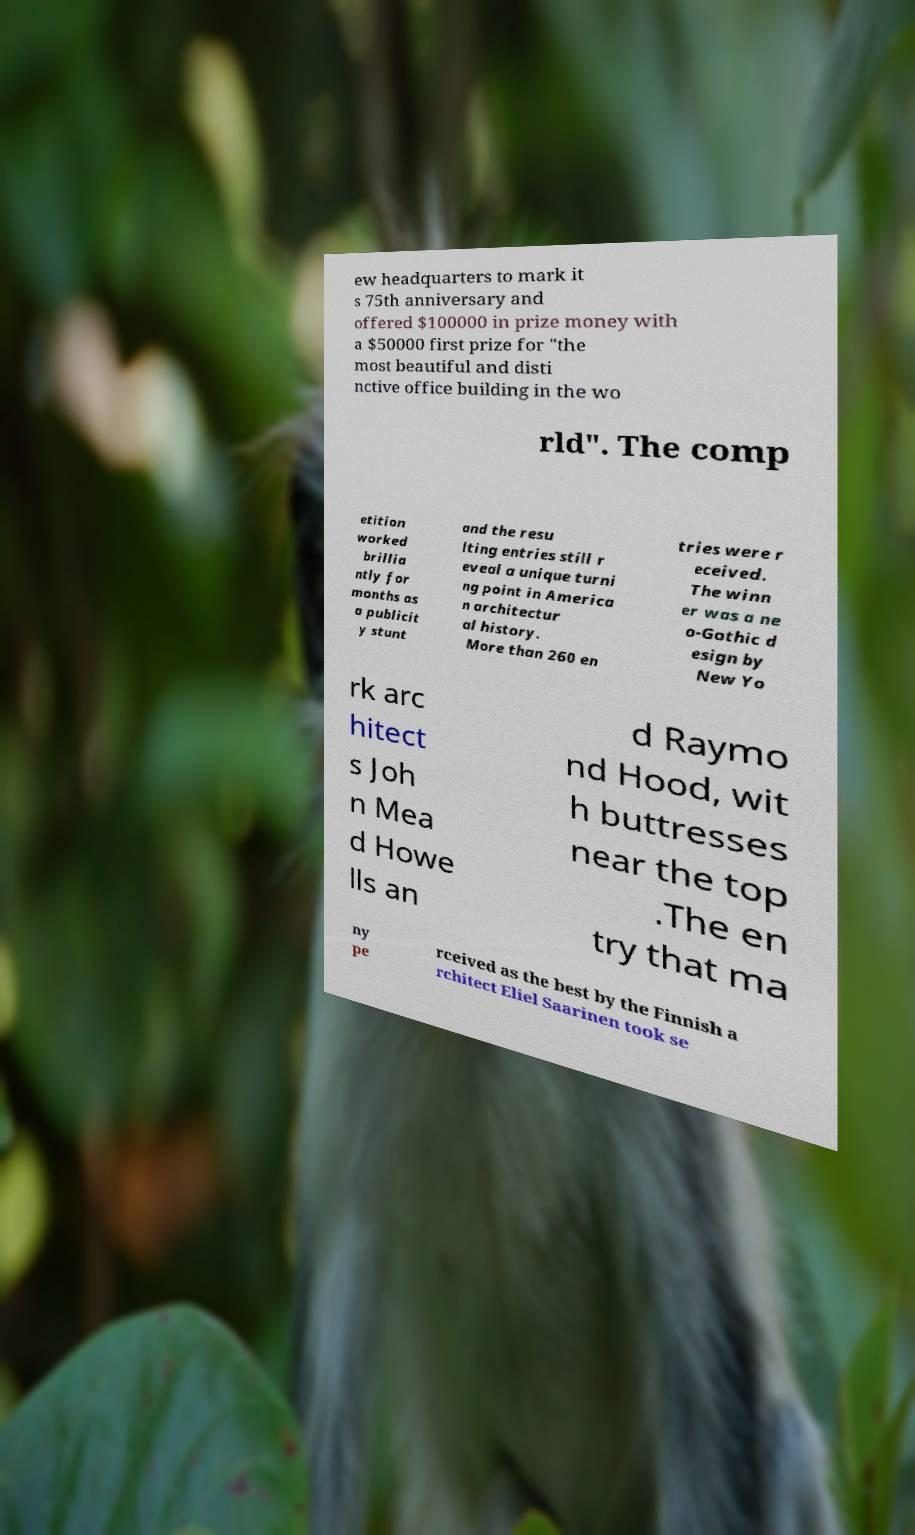Could you assist in decoding the text presented in this image and type it out clearly? ew headquarters to mark it s 75th anniversary and offered $100000 in prize money with a $50000 first prize for "the most beautiful and disti nctive office building in the wo rld". The comp etition worked brillia ntly for months as a publicit y stunt and the resu lting entries still r eveal a unique turni ng point in America n architectur al history. More than 260 en tries were r eceived. The winn er was a ne o-Gothic d esign by New Yo rk arc hitect s Joh n Mea d Howe lls an d Raymo nd Hood, wit h buttresses near the top .The en try that ma ny pe rceived as the best by the Finnish a rchitect Eliel Saarinen took se 